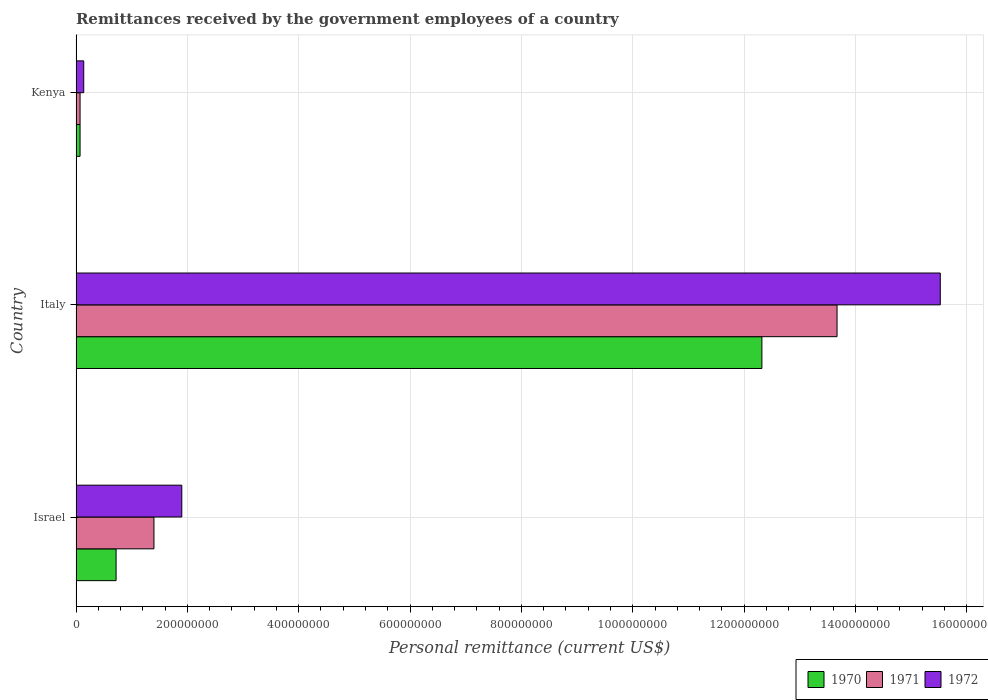How many different coloured bars are there?
Your response must be concise. 3. Are the number of bars per tick equal to the number of legend labels?
Keep it short and to the point. Yes. What is the label of the 3rd group of bars from the top?
Give a very brief answer. Israel. In how many cases, is the number of bars for a given country not equal to the number of legend labels?
Provide a short and direct response. 0. What is the remittances received by the government employees in 1972 in Italy?
Provide a short and direct response. 1.55e+09. Across all countries, what is the maximum remittances received by the government employees in 1970?
Make the answer very short. 1.23e+09. Across all countries, what is the minimum remittances received by the government employees in 1971?
Provide a succinct answer. 7.26e+06. In which country was the remittances received by the government employees in 1970 minimum?
Ensure brevity in your answer.  Kenya. What is the total remittances received by the government employees in 1972 in the graph?
Give a very brief answer. 1.76e+09. What is the difference between the remittances received by the government employees in 1971 in Italy and that in Kenya?
Provide a short and direct response. 1.36e+09. What is the difference between the remittances received by the government employees in 1970 in Israel and the remittances received by the government employees in 1972 in Italy?
Your response must be concise. -1.48e+09. What is the average remittances received by the government employees in 1971 per country?
Your response must be concise. 5.05e+08. What is the difference between the remittances received by the government employees in 1972 and remittances received by the government employees in 1970 in Israel?
Make the answer very short. 1.18e+08. In how many countries, is the remittances received by the government employees in 1971 greater than 240000000 US$?
Give a very brief answer. 1. What is the ratio of the remittances received by the government employees in 1972 in Israel to that in Italy?
Give a very brief answer. 0.12. Is the remittances received by the government employees in 1972 in Israel less than that in Kenya?
Your answer should be very brief. No. What is the difference between the highest and the second highest remittances received by the government employees in 1970?
Your answer should be compact. 1.16e+09. What is the difference between the highest and the lowest remittances received by the government employees in 1972?
Your answer should be very brief. 1.54e+09. Is the sum of the remittances received by the government employees in 1972 in Italy and Kenya greater than the maximum remittances received by the government employees in 1971 across all countries?
Offer a very short reply. Yes. What does the 1st bar from the bottom in Israel represents?
Make the answer very short. 1970. How many bars are there?
Provide a succinct answer. 9. How many countries are there in the graph?
Your answer should be very brief. 3. What is the difference between two consecutive major ticks on the X-axis?
Your response must be concise. 2.00e+08. Does the graph contain any zero values?
Provide a succinct answer. No. Does the graph contain grids?
Offer a terse response. Yes. What is the title of the graph?
Your answer should be very brief. Remittances received by the government employees of a country. What is the label or title of the X-axis?
Your answer should be compact. Personal remittance (current US$). What is the label or title of the Y-axis?
Offer a very short reply. Country. What is the Personal remittance (current US$) in 1970 in Israel?
Your answer should be compact. 7.20e+07. What is the Personal remittance (current US$) in 1971 in Israel?
Provide a short and direct response. 1.40e+08. What is the Personal remittance (current US$) of 1972 in Israel?
Provide a short and direct response. 1.90e+08. What is the Personal remittance (current US$) in 1970 in Italy?
Your answer should be very brief. 1.23e+09. What is the Personal remittance (current US$) of 1971 in Italy?
Your answer should be very brief. 1.37e+09. What is the Personal remittance (current US$) in 1972 in Italy?
Make the answer very short. 1.55e+09. What is the Personal remittance (current US$) in 1970 in Kenya?
Your answer should be compact. 7.26e+06. What is the Personal remittance (current US$) of 1971 in Kenya?
Offer a very short reply. 7.26e+06. What is the Personal remittance (current US$) in 1972 in Kenya?
Keep it short and to the point. 1.39e+07. Across all countries, what is the maximum Personal remittance (current US$) of 1970?
Offer a terse response. 1.23e+09. Across all countries, what is the maximum Personal remittance (current US$) of 1971?
Your answer should be compact. 1.37e+09. Across all countries, what is the maximum Personal remittance (current US$) of 1972?
Provide a short and direct response. 1.55e+09. Across all countries, what is the minimum Personal remittance (current US$) of 1970?
Ensure brevity in your answer.  7.26e+06. Across all countries, what is the minimum Personal remittance (current US$) of 1971?
Ensure brevity in your answer.  7.26e+06. Across all countries, what is the minimum Personal remittance (current US$) in 1972?
Your response must be concise. 1.39e+07. What is the total Personal remittance (current US$) of 1970 in the graph?
Provide a succinct answer. 1.31e+09. What is the total Personal remittance (current US$) of 1971 in the graph?
Your answer should be compact. 1.51e+09. What is the total Personal remittance (current US$) in 1972 in the graph?
Provide a succinct answer. 1.76e+09. What is the difference between the Personal remittance (current US$) in 1970 in Israel and that in Italy?
Offer a terse response. -1.16e+09. What is the difference between the Personal remittance (current US$) of 1971 in Israel and that in Italy?
Provide a succinct answer. -1.23e+09. What is the difference between the Personal remittance (current US$) in 1972 in Israel and that in Italy?
Make the answer very short. -1.36e+09. What is the difference between the Personal remittance (current US$) of 1970 in Israel and that in Kenya?
Provide a succinct answer. 6.47e+07. What is the difference between the Personal remittance (current US$) in 1971 in Israel and that in Kenya?
Ensure brevity in your answer.  1.33e+08. What is the difference between the Personal remittance (current US$) of 1972 in Israel and that in Kenya?
Offer a very short reply. 1.76e+08. What is the difference between the Personal remittance (current US$) in 1970 in Italy and that in Kenya?
Ensure brevity in your answer.  1.22e+09. What is the difference between the Personal remittance (current US$) of 1971 in Italy and that in Kenya?
Make the answer very short. 1.36e+09. What is the difference between the Personal remittance (current US$) of 1972 in Italy and that in Kenya?
Your answer should be compact. 1.54e+09. What is the difference between the Personal remittance (current US$) in 1970 in Israel and the Personal remittance (current US$) in 1971 in Italy?
Your answer should be very brief. -1.30e+09. What is the difference between the Personal remittance (current US$) in 1970 in Israel and the Personal remittance (current US$) in 1972 in Italy?
Provide a succinct answer. -1.48e+09. What is the difference between the Personal remittance (current US$) in 1971 in Israel and the Personal remittance (current US$) in 1972 in Italy?
Keep it short and to the point. -1.41e+09. What is the difference between the Personal remittance (current US$) in 1970 in Israel and the Personal remittance (current US$) in 1971 in Kenya?
Provide a succinct answer. 6.47e+07. What is the difference between the Personal remittance (current US$) in 1970 in Israel and the Personal remittance (current US$) in 1972 in Kenya?
Make the answer very short. 5.81e+07. What is the difference between the Personal remittance (current US$) in 1971 in Israel and the Personal remittance (current US$) in 1972 in Kenya?
Provide a short and direct response. 1.26e+08. What is the difference between the Personal remittance (current US$) in 1970 in Italy and the Personal remittance (current US$) in 1971 in Kenya?
Keep it short and to the point. 1.22e+09. What is the difference between the Personal remittance (current US$) of 1970 in Italy and the Personal remittance (current US$) of 1972 in Kenya?
Give a very brief answer. 1.22e+09. What is the difference between the Personal remittance (current US$) in 1971 in Italy and the Personal remittance (current US$) in 1972 in Kenya?
Ensure brevity in your answer.  1.35e+09. What is the average Personal remittance (current US$) of 1970 per country?
Make the answer very short. 4.37e+08. What is the average Personal remittance (current US$) of 1971 per country?
Keep it short and to the point. 5.05e+08. What is the average Personal remittance (current US$) in 1972 per country?
Offer a very short reply. 5.85e+08. What is the difference between the Personal remittance (current US$) of 1970 and Personal remittance (current US$) of 1971 in Israel?
Keep it short and to the point. -6.80e+07. What is the difference between the Personal remittance (current US$) of 1970 and Personal remittance (current US$) of 1972 in Israel?
Give a very brief answer. -1.18e+08. What is the difference between the Personal remittance (current US$) in 1971 and Personal remittance (current US$) in 1972 in Israel?
Make the answer very short. -5.00e+07. What is the difference between the Personal remittance (current US$) of 1970 and Personal remittance (current US$) of 1971 in Italy?
Offer a terse response. -1.35e+08. What is the difference between the Personal remittance (current US$) of 1970 and Personal remittance (current US$) of 1972 in Italy?
Ensure brevity in your answer.  -3.20e+08. What is the difference between the Personal remittance (current US$) in 1971 and Personal remittance (current US$) in 1972 in Italy?
Offer a terse response. -1.85e+08. What is the difference between the Personal remittance (current US$) in 1970 and Personal remittance (current US$) in 1972 in Kenya?
Your answer should be very brief. -6.60e+06. What is the difference between the Personal remittance (current US$) of 1971 and Personal remittance (current US$) of 1972 in Kenya?
Keep it short and to the point. -6.60e+06. What is the ratio of the Personal remittance (current US$) of 1970 in Israel to that in Italy?
Offer a very short reply. 0.06. What is the ratio of the Personal remittance (current US$) in 1971 in Israel to that in Italy?
Offer a terse response. 0.1. What is the ratio of the Personal remittance (current US$) of 1972 in Israel to that in Italy?
Your answer should be compact. 0.12. What is the ratio of the Personal remittance (current US$) of 1970 in Israel to that in Kenya?
Make the answer very short. 9.92. What is the ratio of the Personal remittance (current US$) in 1971 in Israel to that in Kenya?
Offer a very short reply. 19.28. What is the ratio of the Personal remittance (current US$) in 1972 in Israel to that in Kenya?
Ensure brevity in your answer.  13.71. What is the ratio of the Personal remittance (current US$) in 1970 in Italy to that in Kenya?
Ensure brevity in your answer.  169.7. What is the ratio of the Personal remittance (current US$) of 1971 in Italy to that in Kenya?
Make the answer very short. 188.29. What is the ratio of the Personal remittance (current US$) of 1972 in Italy to that in Kenya?
Your response must be concise. 112.01. What is the difference between the highest and the second highest Personal remittance (current US$) of 1970?
Offer a very short reply. 1.16e+09. What is the difference between the highest and the second highest Personal remittance (current US$) of 1971?
Offer a terse response. 1.23e+09. What is the difference between the highest and the second highest Personal remittance (current US$) in 1972?
Offer a terse response. 1.36e+09. What is the difference between the highest and the lowest Personal remittance (current US$) in 1970?
Give a very brief answer. 1.22e+09. What is the difference between the highest and the lowest Personal remittance (current US$) of 1971?
Offer a terse response. 1.36e+09. What is the difference between the highest and the lowest Personal remittance (current US$) of 1972?
Make the answer very short. 1.54e+09. 